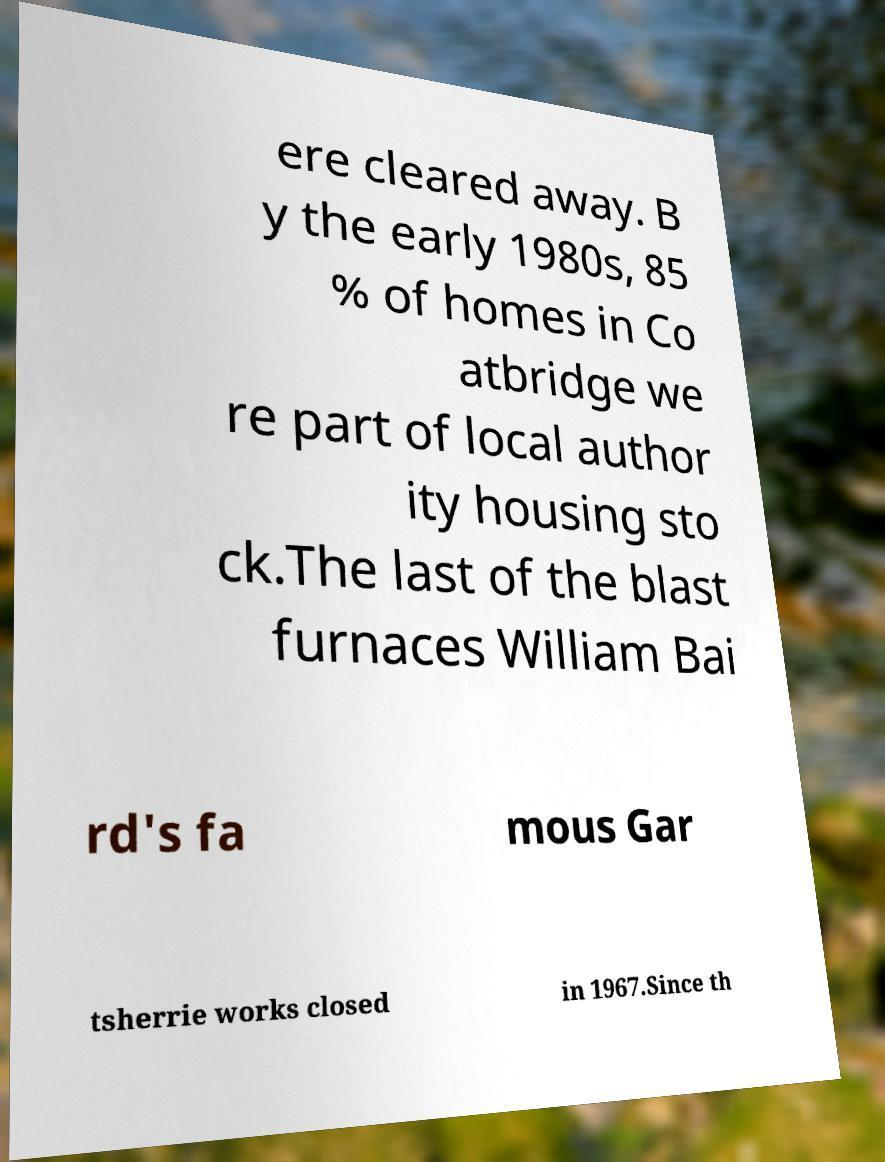Can you accurately transcribe the text from the provided image for me? ere cleared away. B y the early 1980s, 85 % of homes in Co atbridge we re part of local author ity housing sto ck.The last of the blast furnaces William Bai rd's fa mous Gar tsherrie works closed in 1967.Since th 